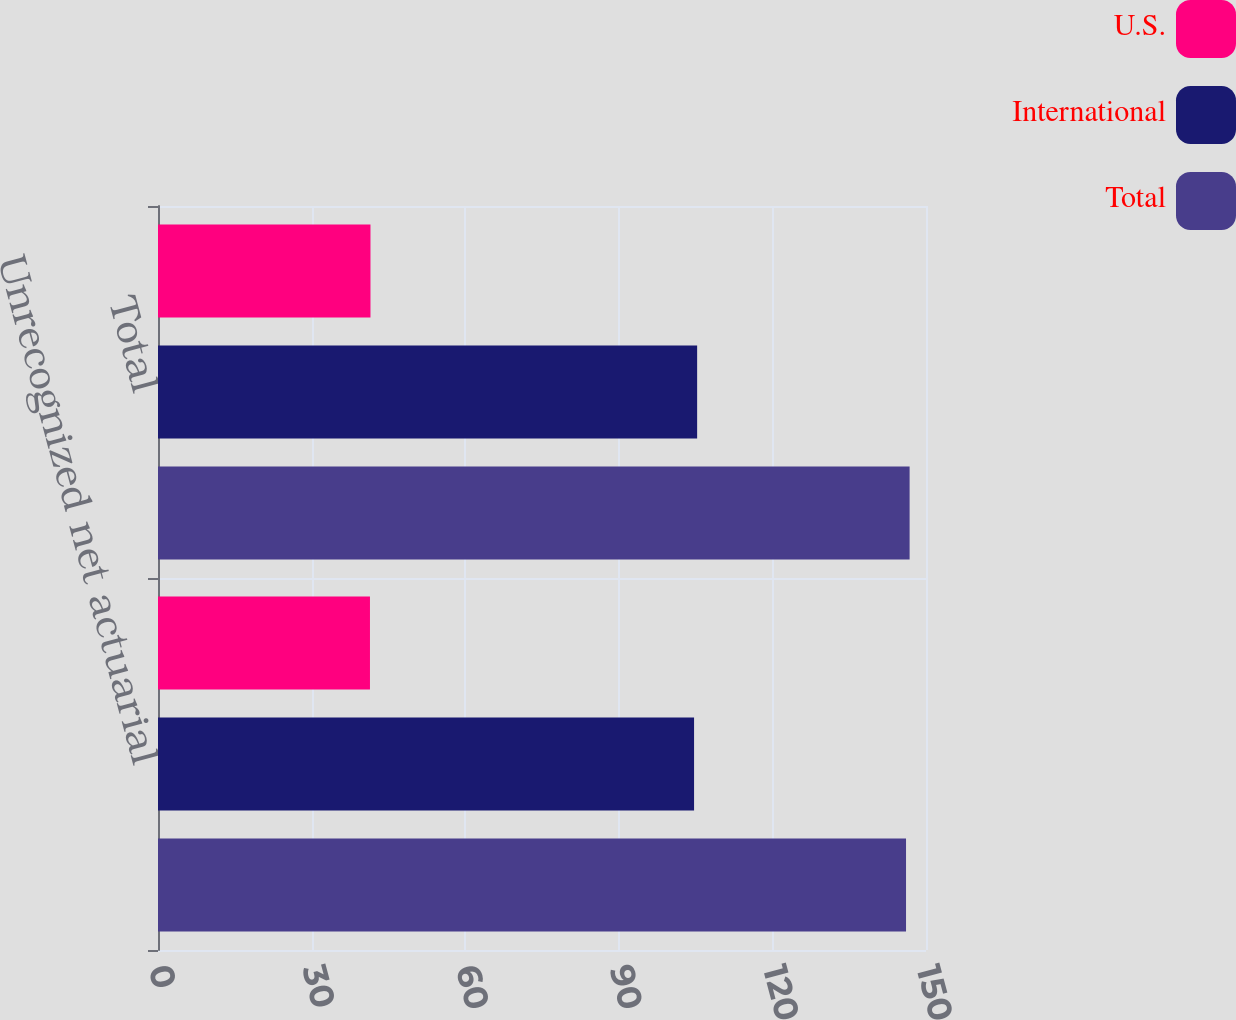Convert chart to OTSL. <chart><loc_0><loc_0><loc_500><loc_500><stacked_bar_chart><ecel><fcel>Unrecognized net actuarial<fcel>Total<nl><fcel>U.S.<fcel>41.4<fcel>41.5<nl><fcel>International<fcel>104.7<fcel>105.3<nl><fcel>Total<fcel>146.1<fcel>146.8<nl></chart> 